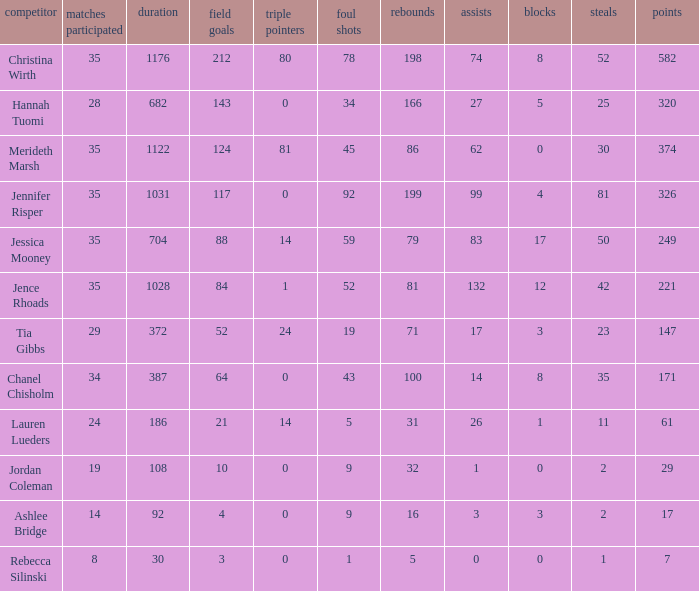What is the lowest number of games played by the player with 50 steals? 35.0. 